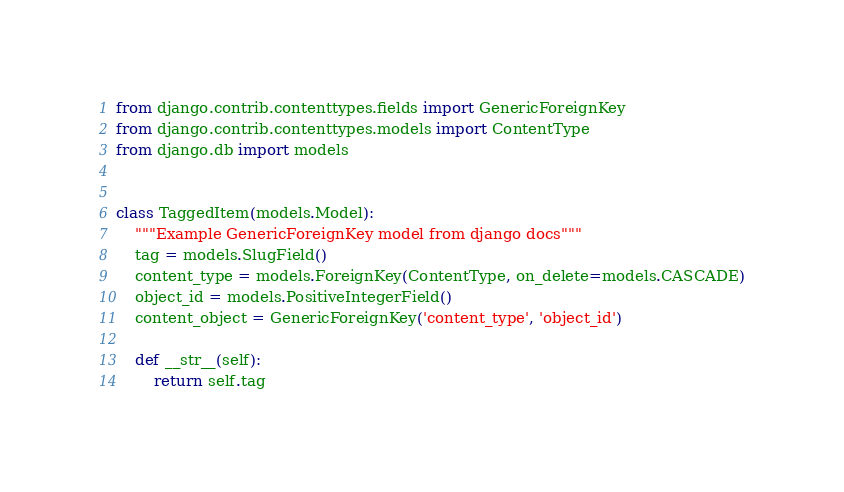Convert code to text. <code><loc_0><loc_0><loc_500><loc_500><_Python_>from django.contrib.contenttypes.fields import GenericForeignKey
from django.contrib.contenttypes.models import ContentType
from django.db import models


class TaggedItem(models.Model):
    """Example GenericForeignKey model from django docs"""
    tag = models.SlugField()
    content_type = models.ForeignKey(ContentType, on_delete=models.CASCADE)
    object_id = models.PositiveIntegerField()
    content_object = GenericForeignKey('content_type', 'object_id')

    def __str__(self):
        return self.tag
</code> 